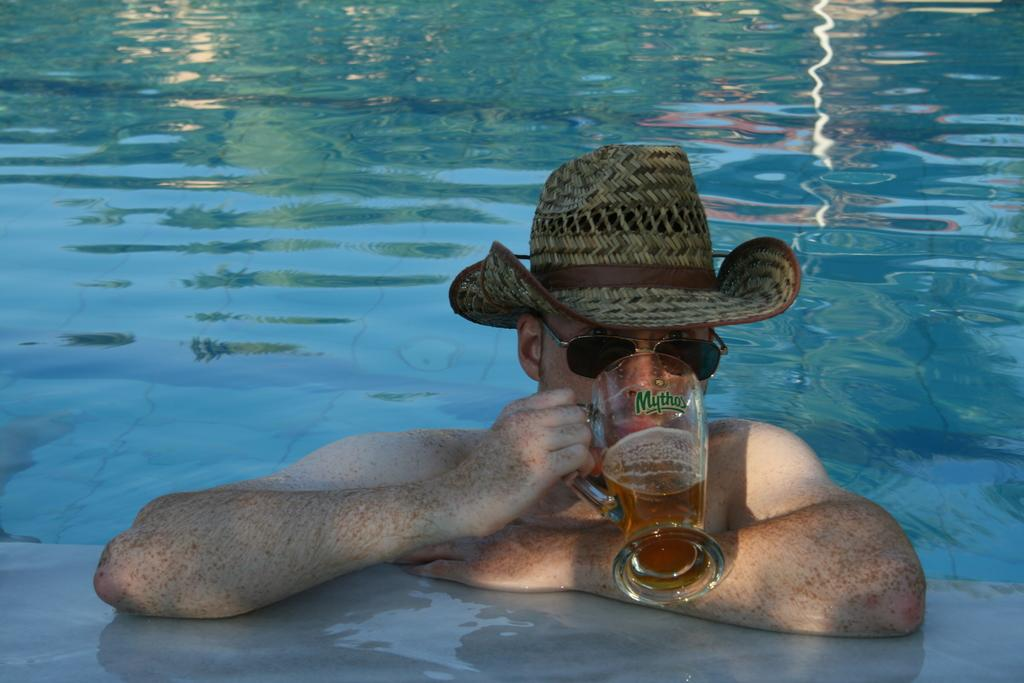What is the man doing in the swimming pool? The man is in the swimming pool. What accessories is the man wearing? The man is wearing a hat and sunglasses. What is the man holding in the image? The man is holding a jug of wine. What activity is the man performing with the jug of wine? A: The man is drinking from the jug of wine. What type of reaction can be seen from the frogs in the image? There are no frogs present in the image, so it is not possible to observe any reactions from them. 